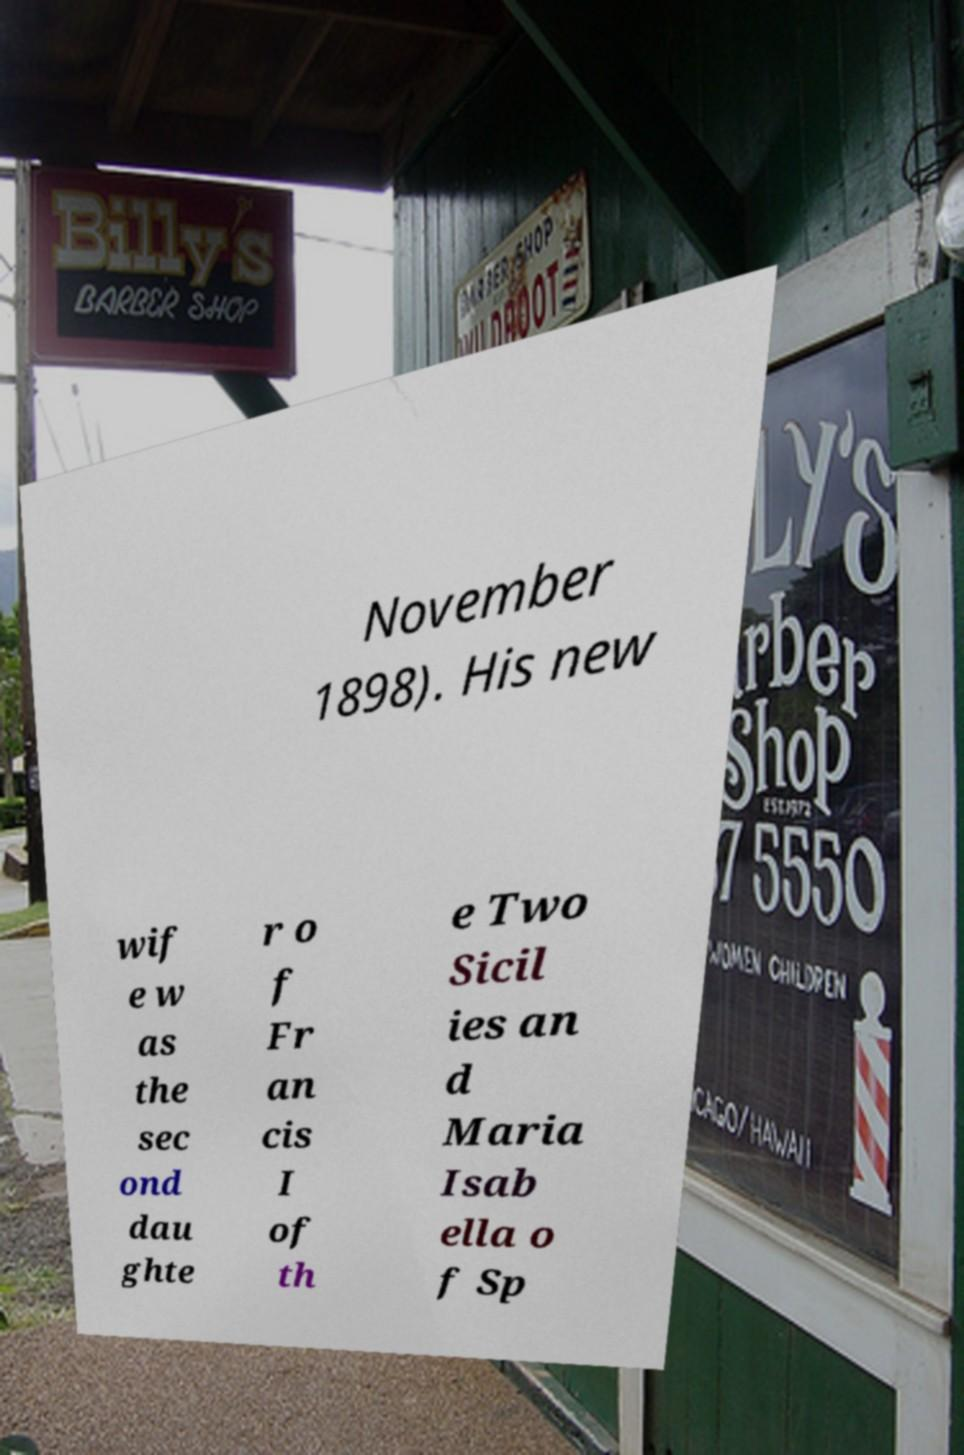I need the written content from this picture converted into text. Can you do that? November 1898). His new wif e w as the sec ond dau ghte r o f Fr an cis I of th e Two Sicil ies an d Maria Isab ella o f Sp 